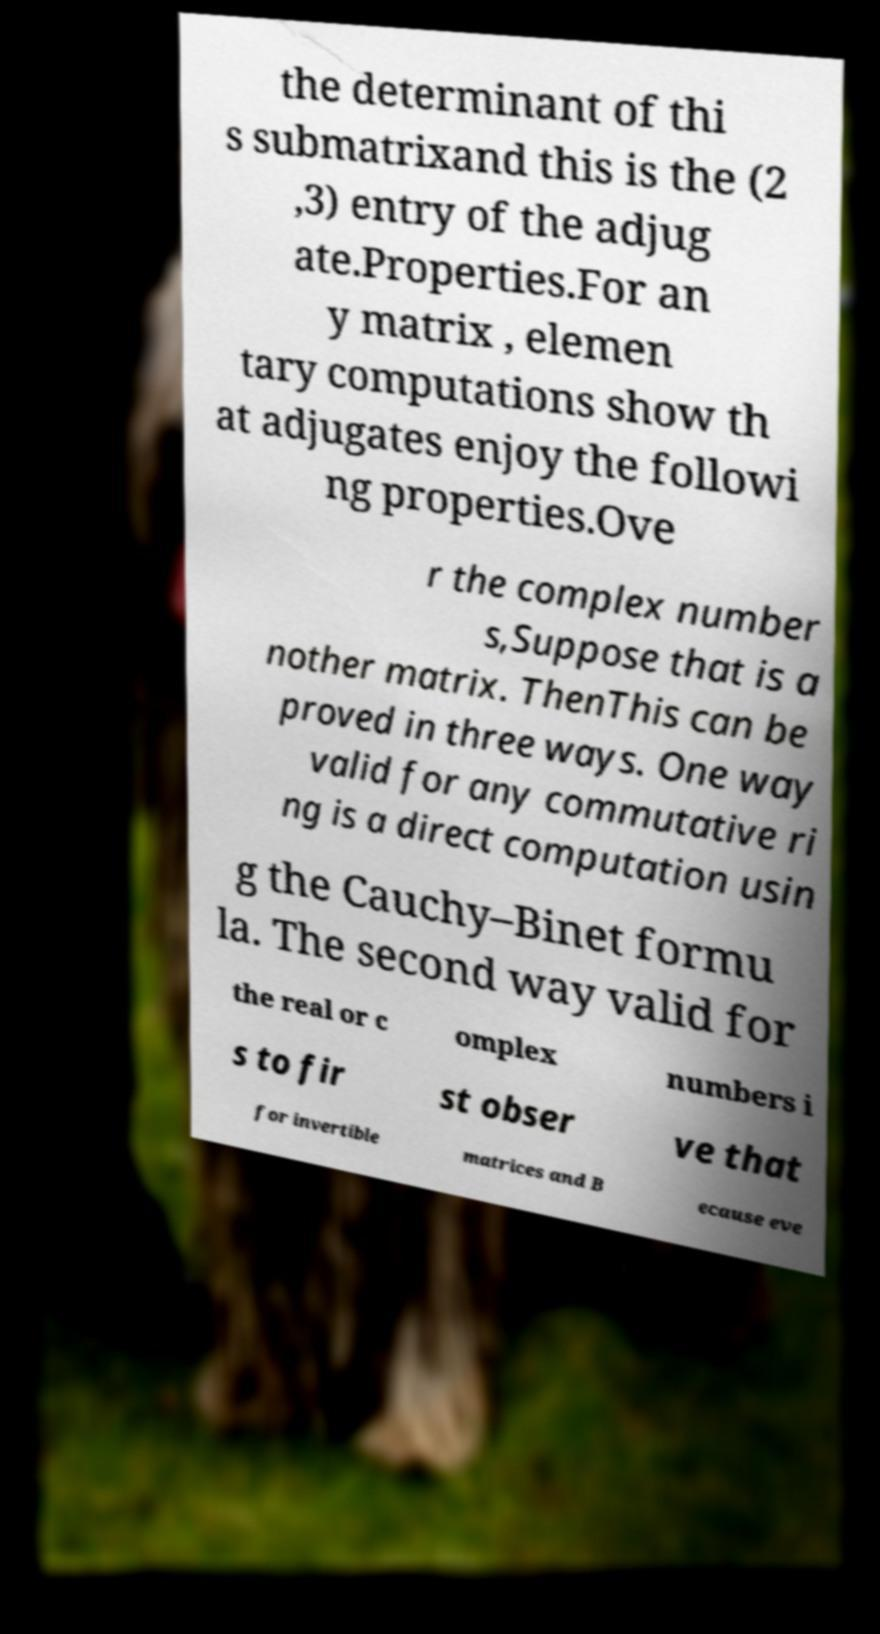I need the written content from this picture converted into text. Can you do that? the determinant of thi s submatrixand this is the (2 ,3) entry of the adjug ate.Properties.For an y matrix , elemen tary computations show th at adjugates enjoy the followi ng properties.Ove r the complex number s,Suppose that is a nother matrix. ThenThis can be proved in three ways. One way valid for any commutative ri ng is a direct computation usin g the Cauchy–Binet formu la. The second way valid for the real or c omplex numbers i s to fir st obser ve that for invertible matrices and B ecause eve 